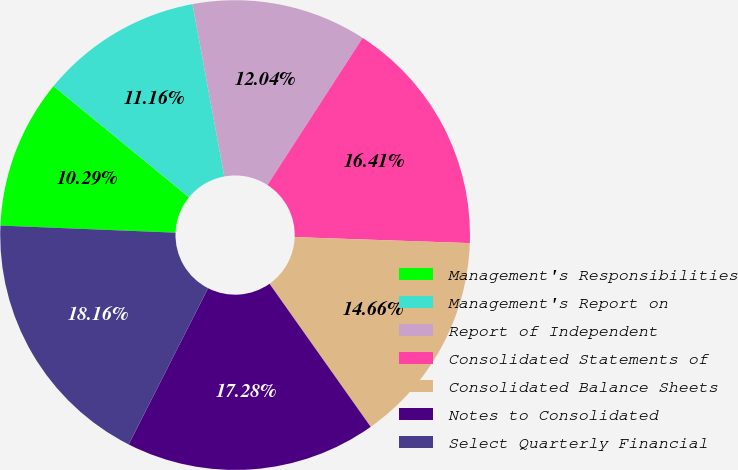Convert chart. <chart><loc_0><loc_0><loc_500><loc_500><pie_chart><fcel>Management's Responsibilities<fcel>Management's Report on<fcel>Report of Independent<fcel>Consolidated Statements of<fcel>Consolidated Balance Sheets<fcel>Notes to Consolidated<fcel>Select Quarterly Financial<nl><fcel>10.29%<fcel>11.16%<fcel>12.04%<fcel>16.41%<fcel>14.66%<fcel>17.28%<fcel>18.16%<nl></chart> 